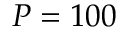Convert formula to latex. <formula><loc_0><loc_0><loc_500><loc_500>P = 1 0 0</formula> 